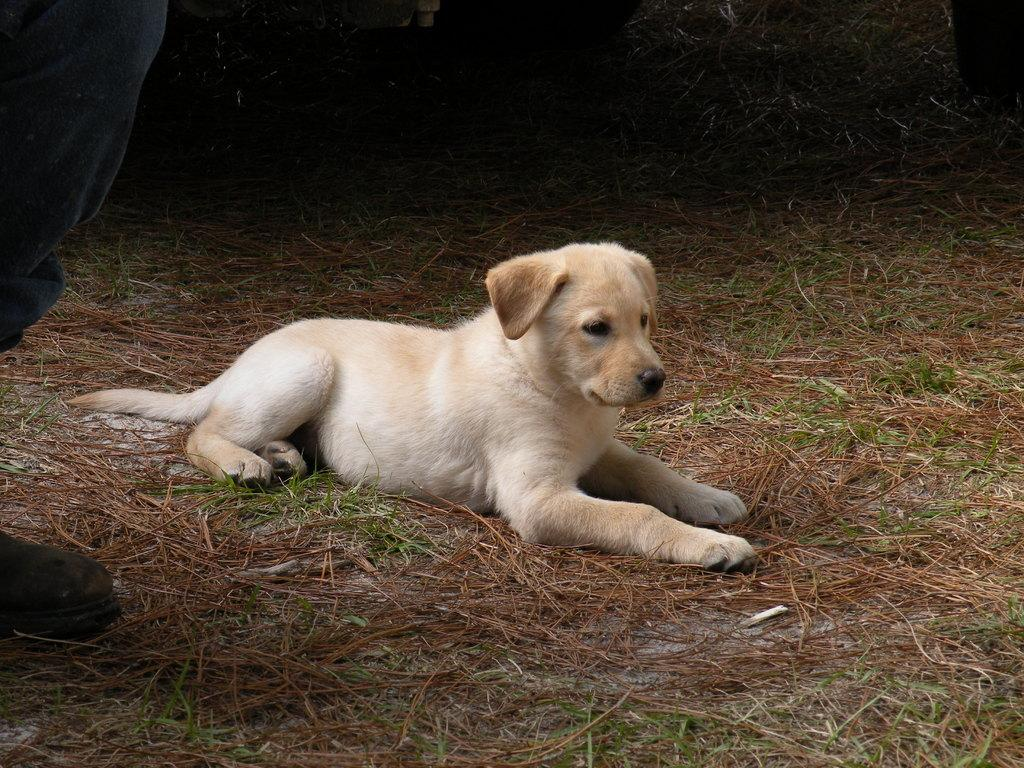What is the main subject in the center of the image? There is a dog in the center of the image. What type of surface is at the bottom of the image? There is grass at the bottom of the image. Can you describe any part of a person in the image? A person's leg is visible on the left side of the image. What type of soup is being served at the seashore in the image? There is no soup or seashore present in the image; it features a dog and grass. Can you tell me how many bottles are visible in the image? There are no bottles present in the image. 